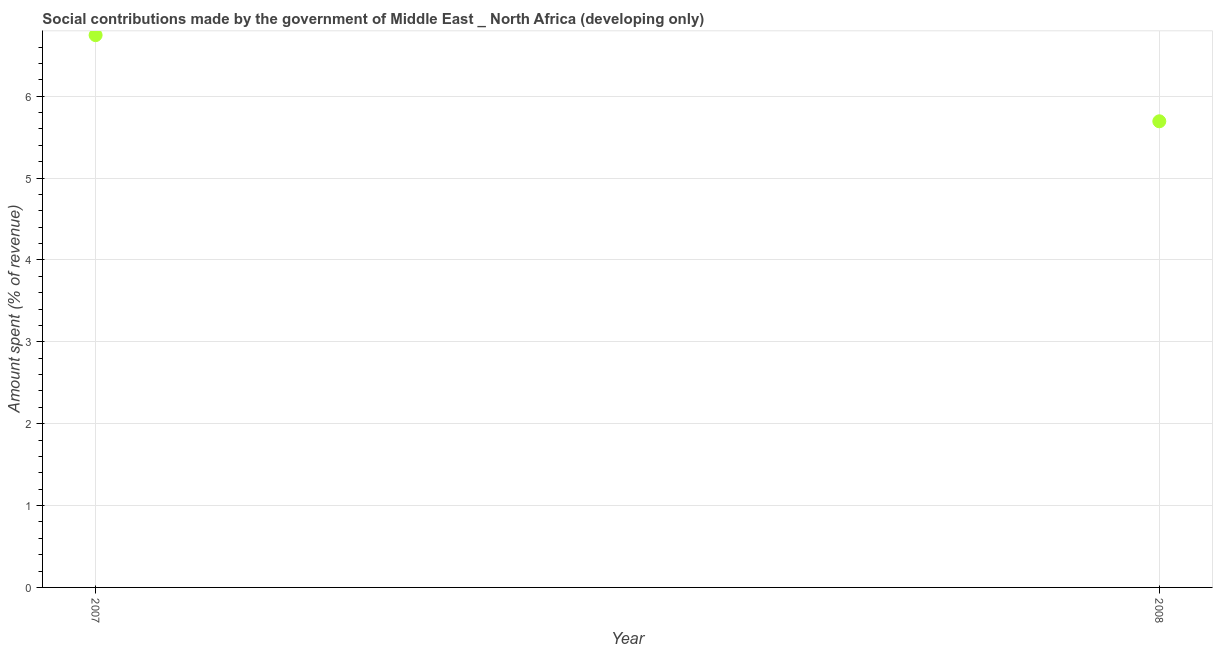What is the amount spent in making social contributions in 2007?
Keep it short and to the point. 6.75. Across all years, what is the maximum amount spent in making social contributions?
Provide a short and direct response. 6.75. Across all years, what is the minimum amount spent in making social contributions?
Offer a terse response. 5.69. In which year was the amount spent in making social contributions maximum?
Give a very brief answer. 2007. In which year was the amount spent in making social contributions minimum?
Provide a succinct answer. 2008. What is the sum of the amount spent in making social contributions?
Provide a succinct answer. 12.44. What is the difference between the amount spent in making social contributions in 2007 and 2008?
Give a very brief answer. 1.05. What is the average amount spent in making social contributions per year?
Keep it short and to the point. 6.22. What is the median amount spent in making social contributions?
Your answer should be very brief. 6.22. Do a majority of the years between 2007 and 2008 (inclusive) have amount spent in making social contributions greater than 5.8 %?
Give a very brief answer. No. What is the ratio of the amount spent in making social contributions in 2007 to that in 2008?
Make the answer very short. 1.18. Is the amount spent in making social contributions in 2007 less than that in 2008?
Give a very brief answer. No. Does the amount spent in making social contributions monotonically increase over the years?
Give a very brief answer. No. How many dotlines are there?
Your answer should be compact. 1. How many years are there in the graph?
Your answer should be compact. 2. What is the difference between two consecutive major ticks on the Y-axis?
Make the answer very short. 1. Are the values on the major ticks of Y-axis written in scientific E-notation?
Ensure brevity in your answer.  No. What is the title of the graph?
Offer a terse response. Social contributions made by the government of Middle East _ North Africa (developing only). What is the label or title of the X-axis?
Provide a succinct answer. Year. What is the label or title of the Y-axis?
Your answer should be very brief. Amount spent (% of revenue). What is the Amount spent (% of revenue) in 2007?
Your answer should be very brief. 6.75. What is the Amount spent (% of revenue) in 2008?
Ensure brevity in your answer.  5.69. What is the difference between the Amount spent (% of revenue) in 2007 and 2008?
Make the answer very short. 1.05. What is the ratio of the Amount spent (% of revenue) in 2007 to that in 2008?
Provide a short and direct response. 1.19. 